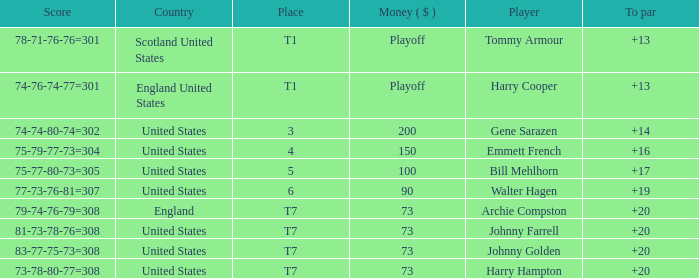What is the ranking for the United States when the money is $200? 3.0. 